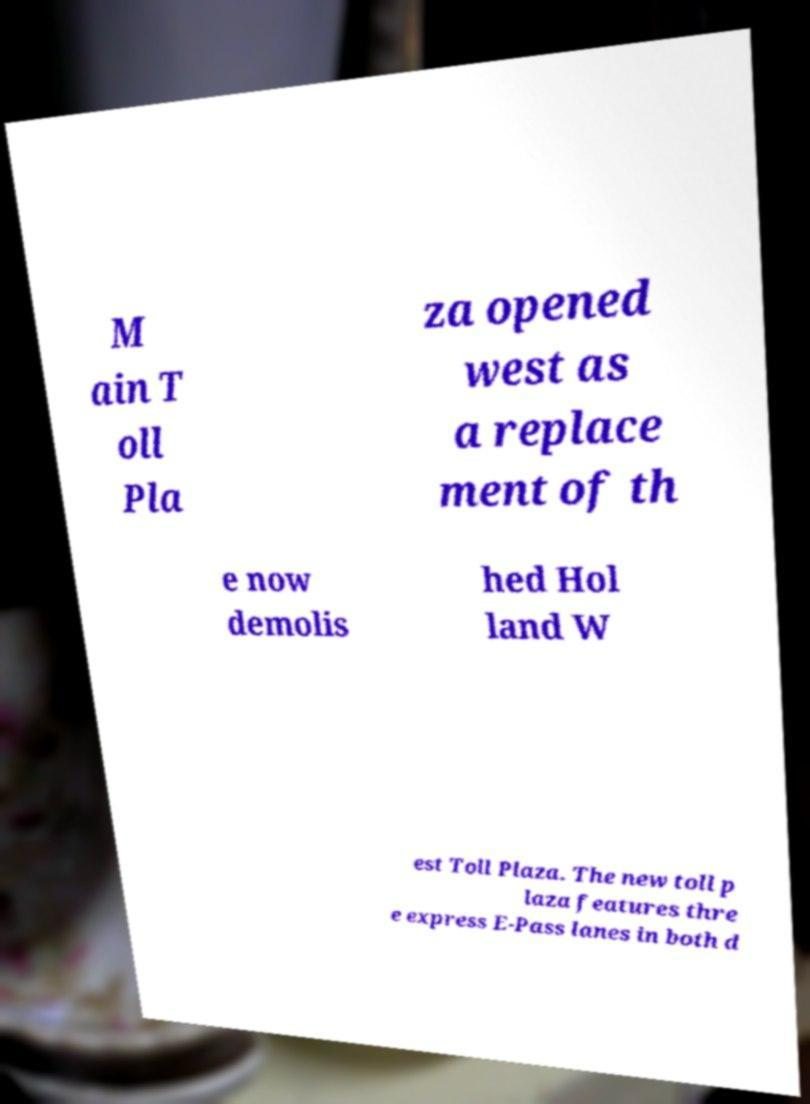Could you extract and type out the text from this image? M ain T oll Pla za opened west as a replace ment of th e now demolis hed Hol land W est Toll Plaza. The new toll p laza features thre e express E-Pass lanes in both d 